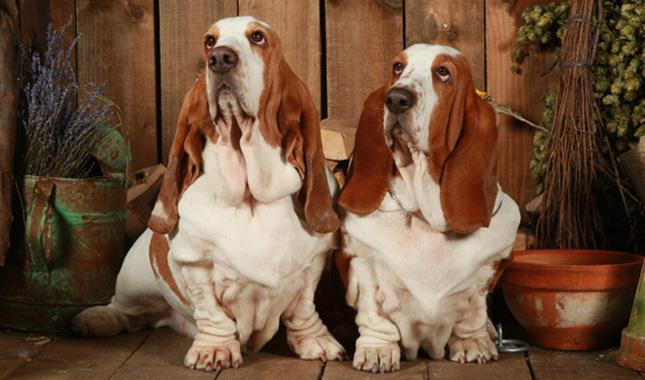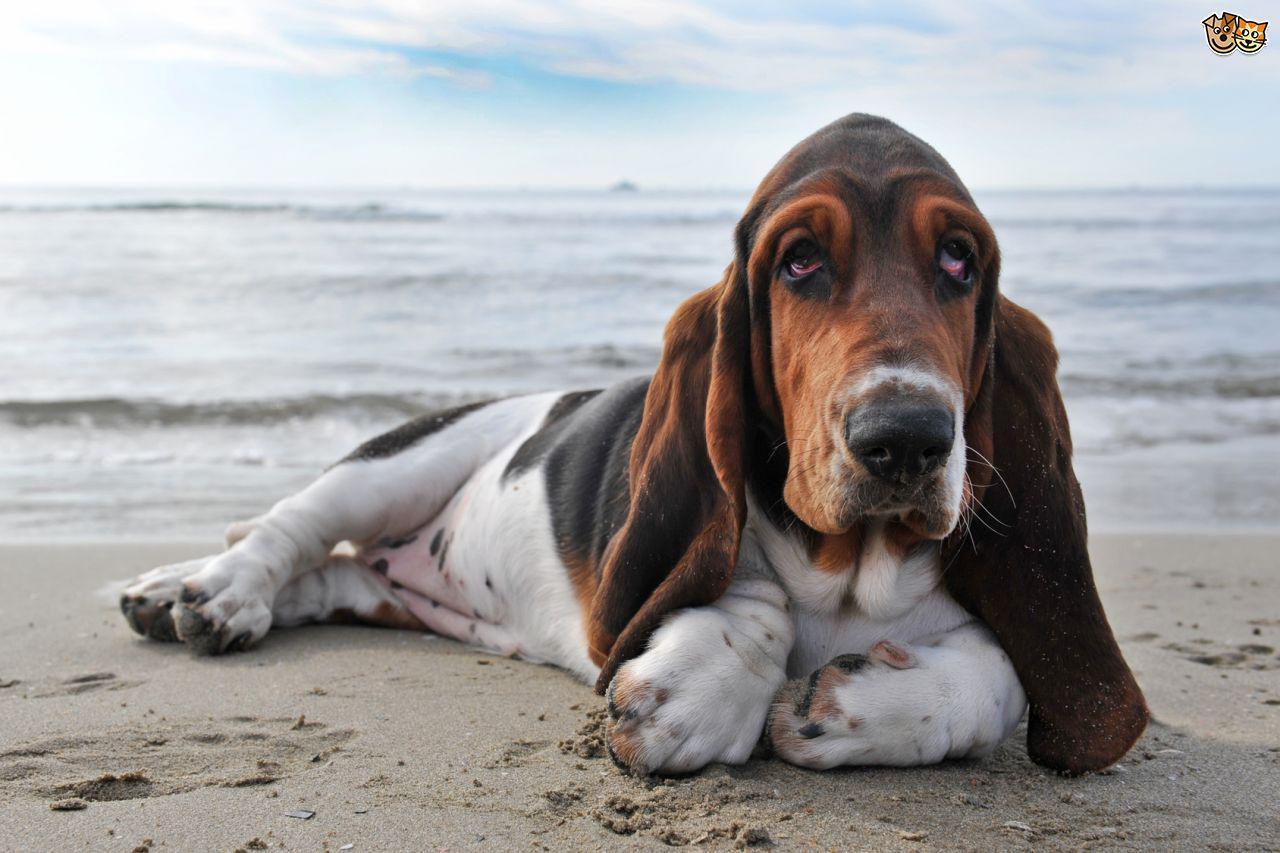The first image is the image on the left, the second image is the image on the right. Assess this claim about the two images: "There are dogs running on pavement.". Correct or not? Answer yes or no. No. 